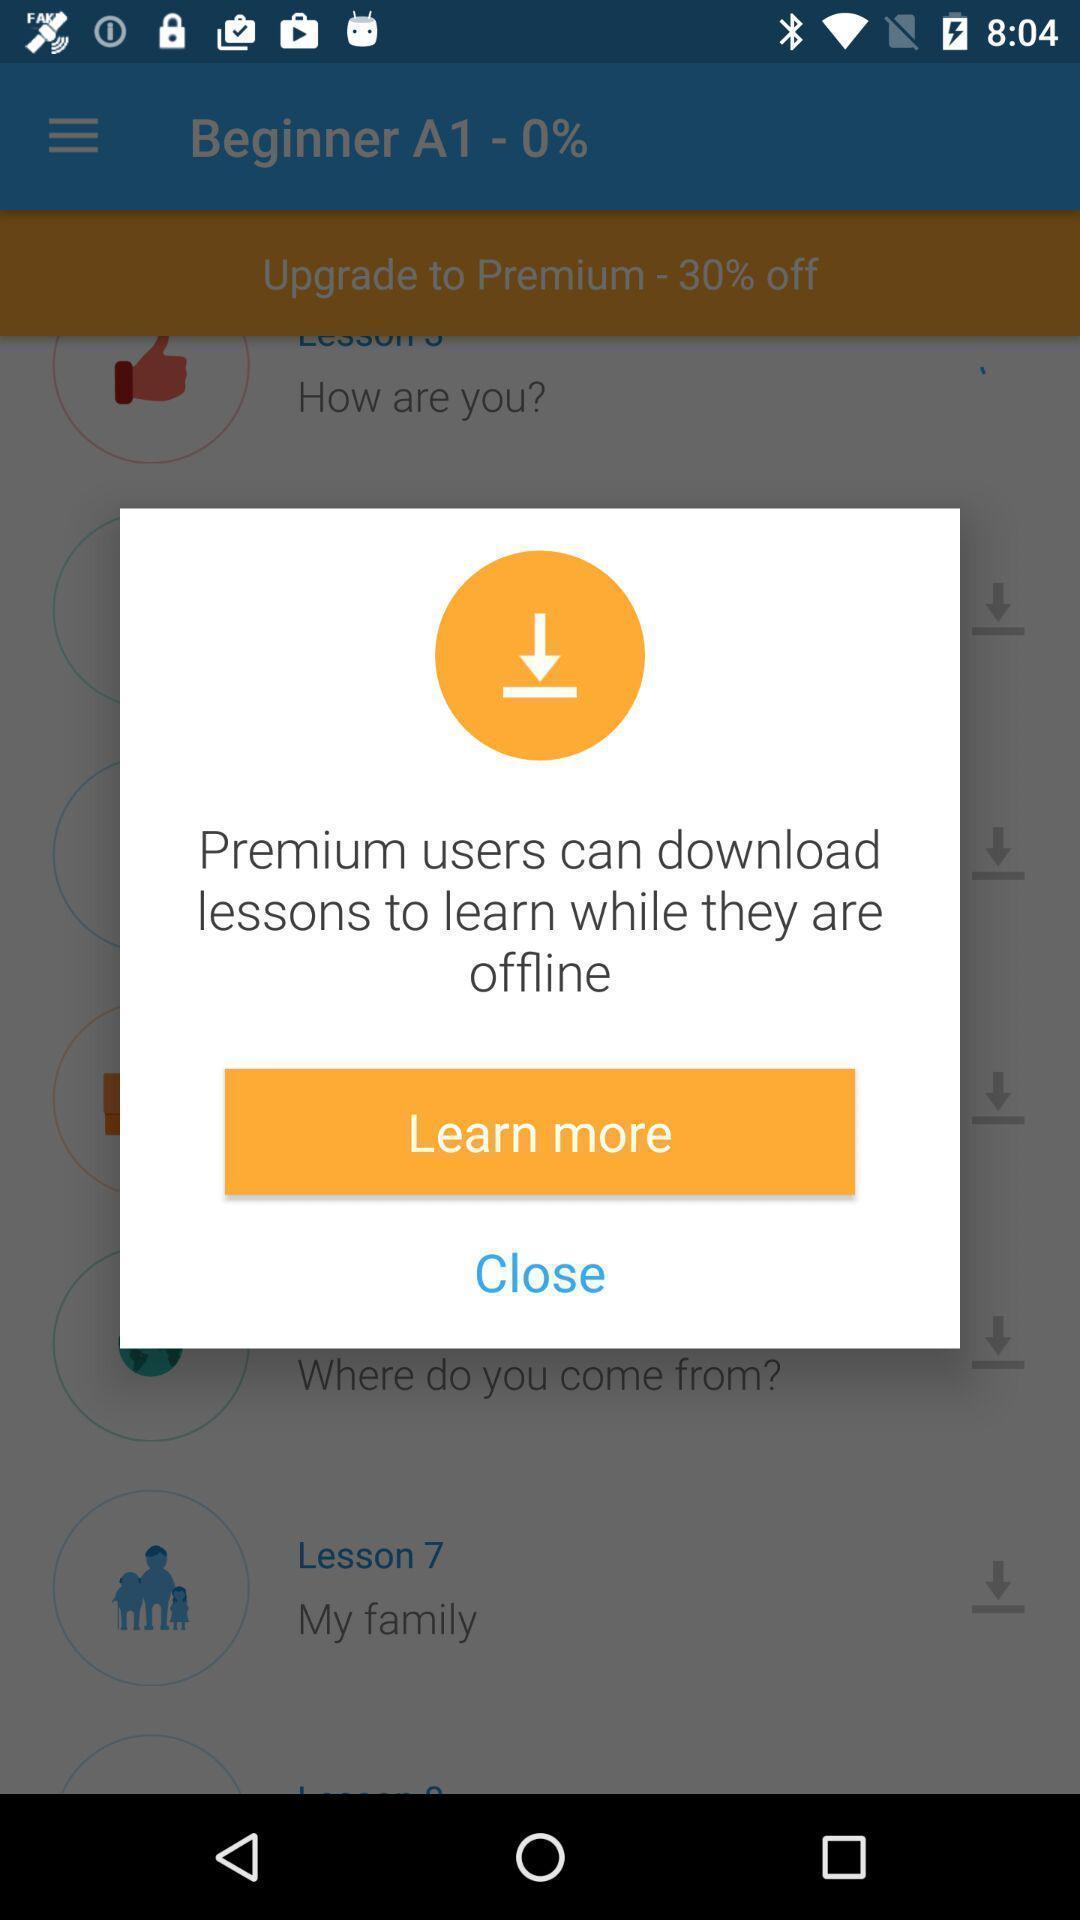What can you discern from this picture? Pop-up window showing information about premium members. 